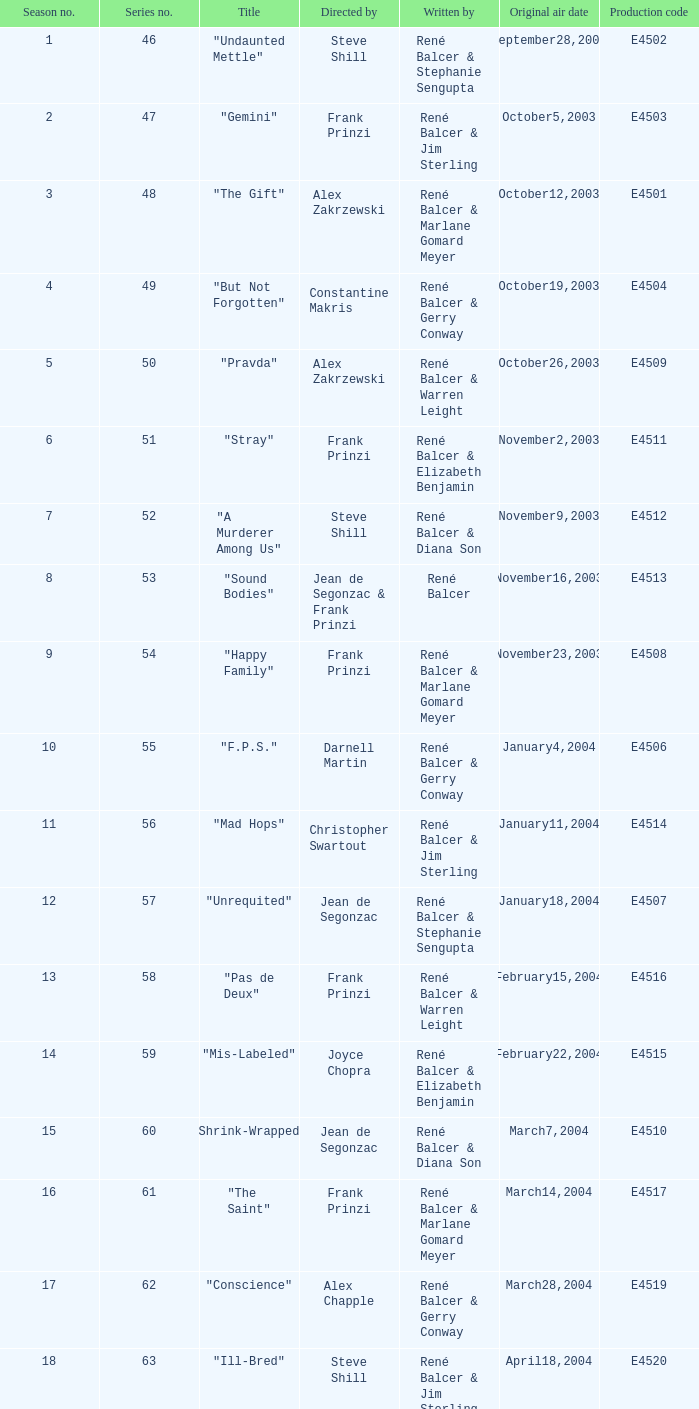On which date was "d.a.w." initially broadcasted? May16,2004. 